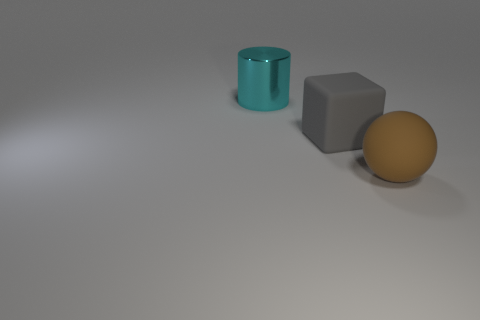Add 1 cyan rubber blocks. How many objects exist? 4 Subtract all cylinders. How many objects are left? 2 Subtract 0 gray balls. How many objects are left? 3 Subtract all big blue shiny things. Subtract all cyan things. How many objects are left? 2 Add 1 big brown rubber objects. How many big brown rubber objects are left? 2 Add 3 large cubes. How many large cubes exist? 4 